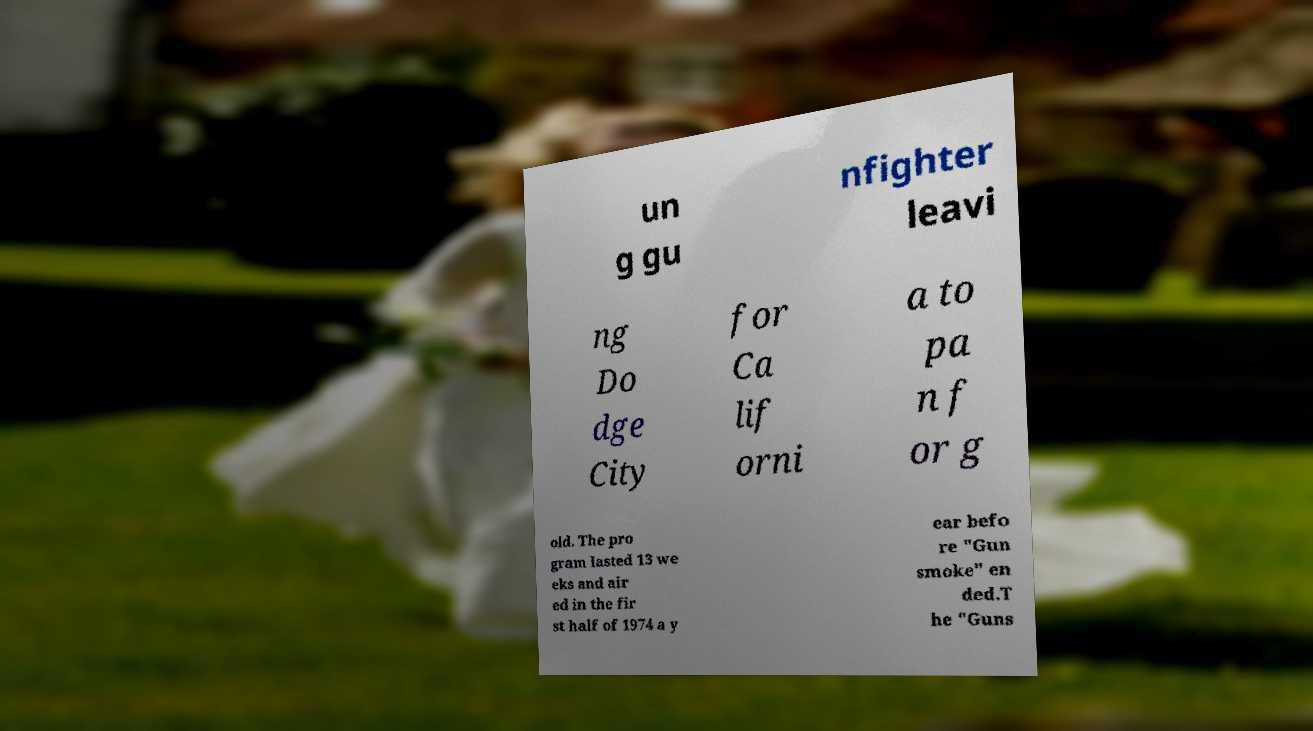Can you accurately transcribe the text from the provided image for me? un g gu nfighter leavi ng Do dge City for Ca lif orni a to pa n f or g old. The pro gram lasted 13 we eks and air ed in the fir st half of 1974 a y ear befo re "Gun smoke" en ded.T he "Guns 